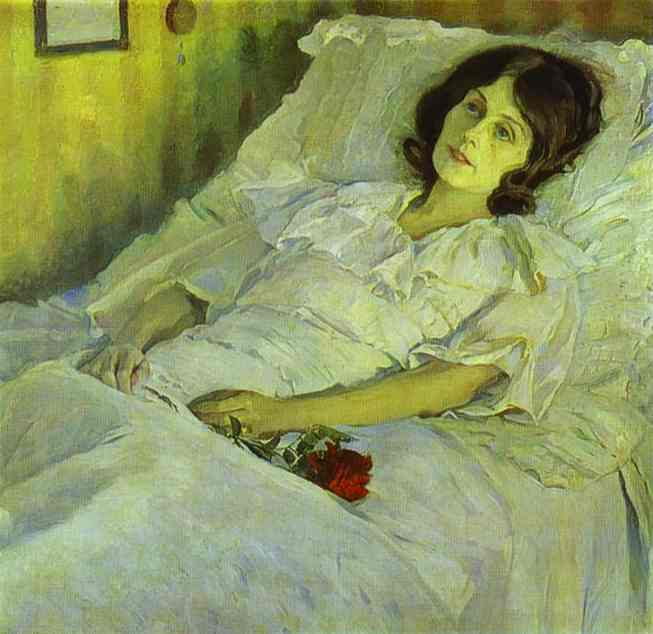Can you tell me about the significance of the flowers in this painting? In this painting, the red flowers held by the woman could symbolize a range of emotions or themes, such as love, passion, or even grief. Flowers often carry rich symbolic meanings in art, and their vibrant color amidst the otherwise muted palette dramatically draws the viewer's attention, perhaps signifying an important emotional anchor in the subject's life or in the narrative suggested by the artwork. 